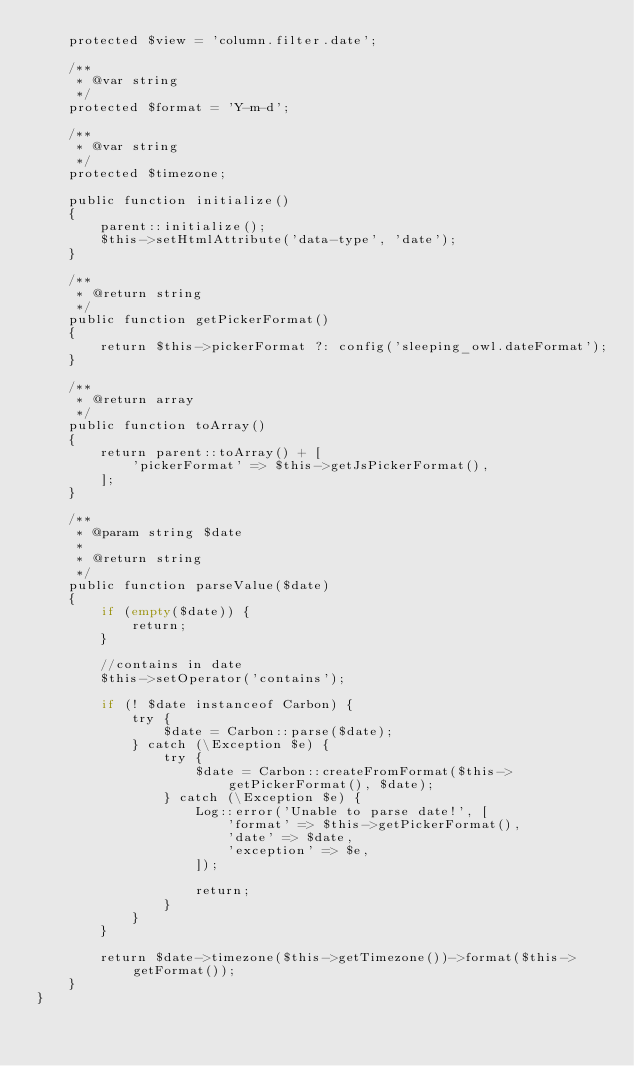Convert code to text. <code><loc_0><loc_0><loc_500><loc_500><_PHP_>    protected $view = 'column.filter.date';

    /**
     * @var string
     */
    protected $format = 'Y-m-d';

    /**
     * @var string
     */
    protected $timezone;

    public function initialize()
    {
        parent::initialize();
        $this->setHtmlAttribute('data-type', 'date');
    }

    /**
     * @return string
     */
    public function getPickerFormat()
    {
        return $this->pickerFormat ?: config('sleeping_owl.dateFormat');
    }

    /**
     * @return array
     */
    public function toArray()
    {
        return parent::toArray() + [
            'pickerFormat' => $this->getJsPickerFormat(),
        ];
    }

    /**
     * @param string $date
     *
     * @return string
     */
    public function parseValue($date)
    {
        if (empty($date)) {
            return;
        }

        //contains in date
        $this->setOperator('contains');

        if (! $date instanceof Carbon) {
            try {
                $date = Carbon::parse($date);
            } catch (\Exception $e) {
                try {
                    $date = Carbon::createFromFormat($this->getPickerFormat(), $date);
                } catch (\Exception $e) {
                    Log::error('Unable to parse date!', [
                        'format' => $this->getPickerFormat(),
                        'date' => $date,
                        'exception' => $e,
                    ]);

                    return;
                }
            }
        }

        return $date->timezone($this->getTimezone())->format($this->getFormat());
    }
}
</code> 